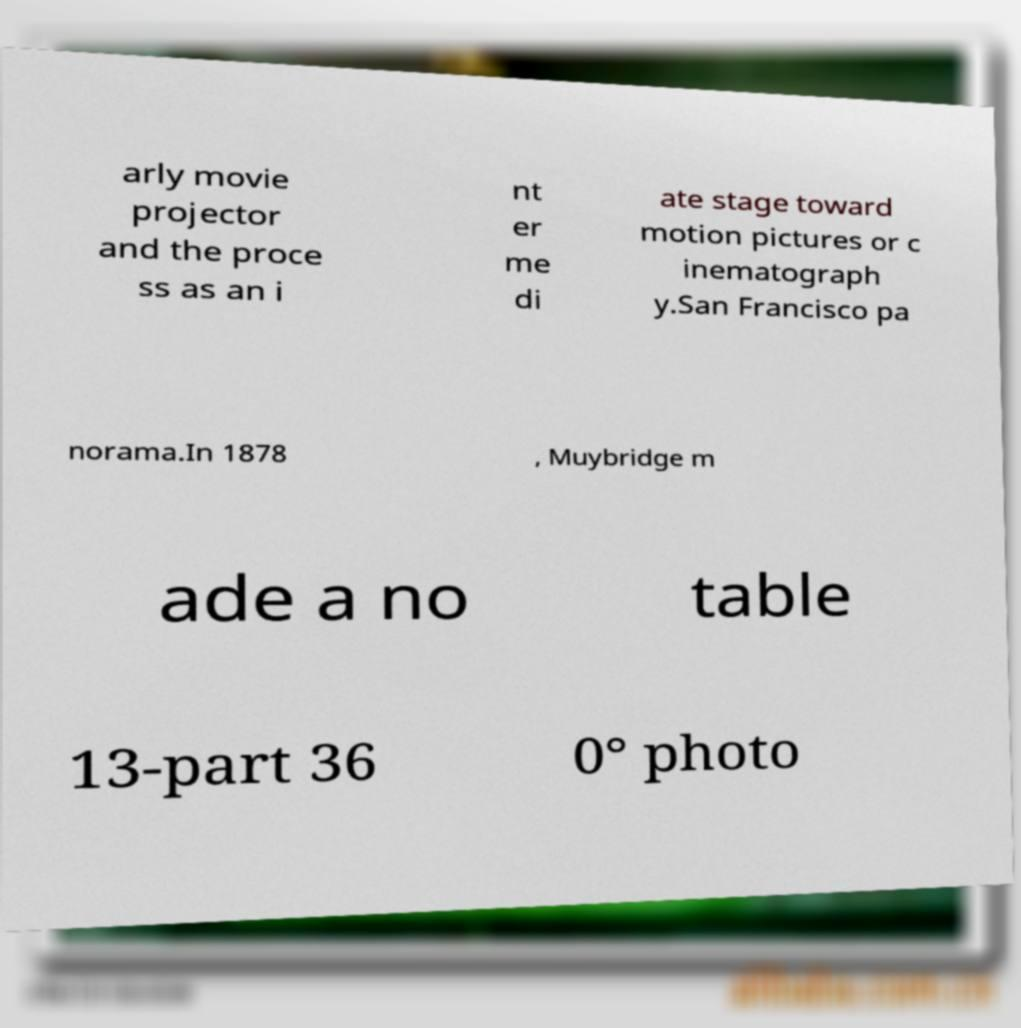For documentation purposes, I need the text within this image transcribed. Could you provide that? arly movie projector and the proce ss as an i nt er me di ate stage toward motion pictures or c inematograph y.San Francisco pa norama.In 1878 , Muybridge m ade a no table 13-part 36 0° photo 